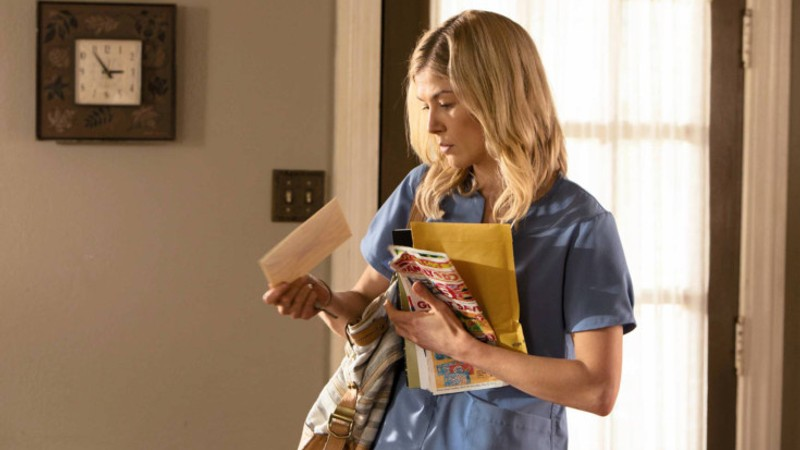What might be the significance of the items she is carrying? The items she carries, a manila folder and a tote bag, likely hold importance for her duties. The folder probably contains patient records or medical documents relevant to her visits, while the tote bag might carry essential nursing supplies or personal items, reflecting a blend of professional responsibilities and personal needs in her role. 